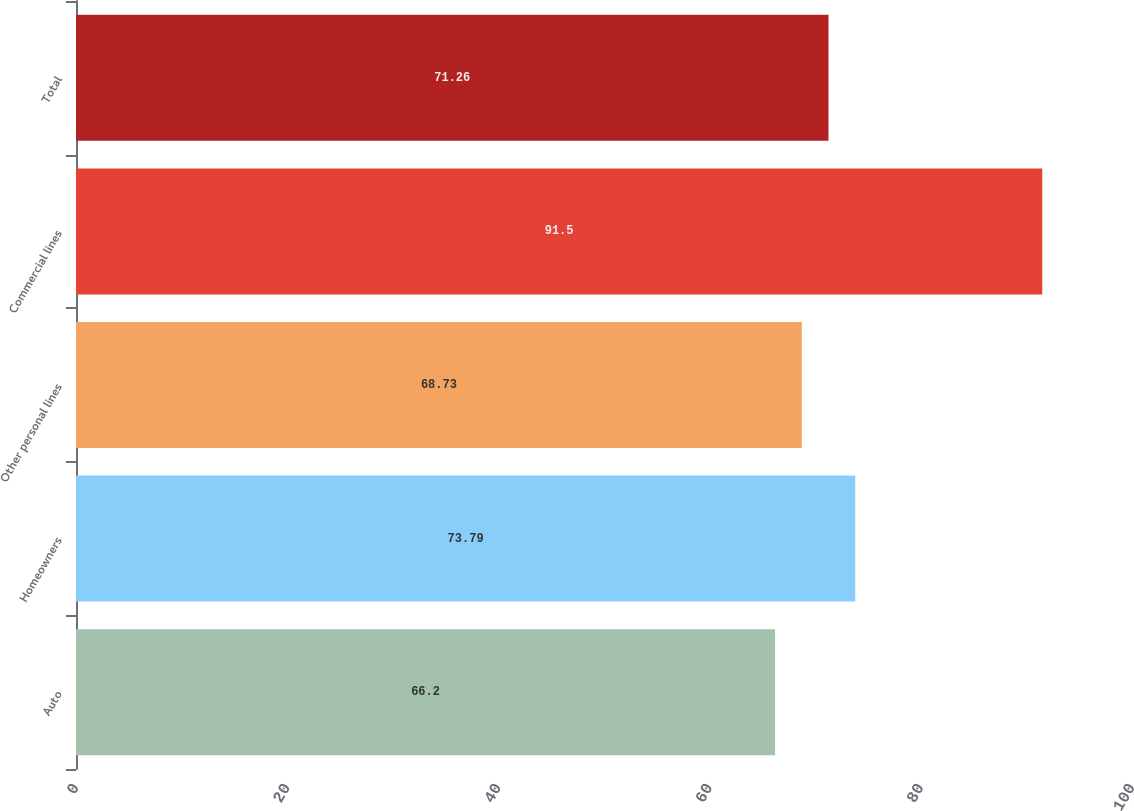<chart> <loc_0><loc_0><loc_500><loc_500><bar_chart><fcel>Auto<fcel>Homeowners<fcel>Other personal lines<fcel>Commercial lines<fcel>Total<nl><fcel>66.2<fcel>73.79<fcel>68.73<fcel>91.5<fcel>71.26<nl></chart> 